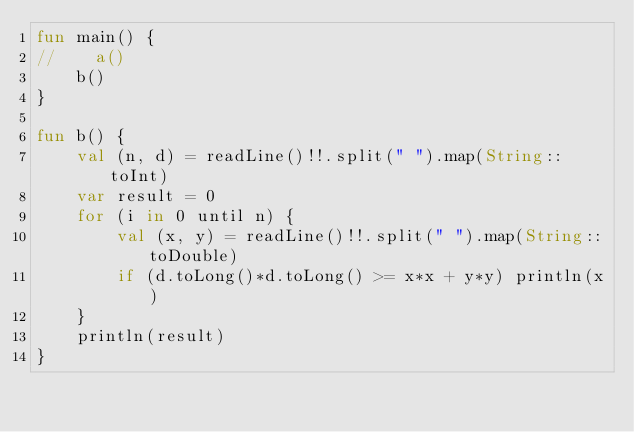<code> <loc_0><loc_0><loc_500><loc_500><_Kotlin_>fun main() {
//    a()
    b()
}

fun b() {
    val (n, d) = readLine()!!.split(" ").map(String::toInt)
    var result = 0
    for (i in 0 until n) {
        val (x, y) = readLine()!!.split(" ").map(String::toDouble)
        if (d.toLong()*d.toLong() >= x*x + y*y) println(x)
    }
    println(result)
}</code> 